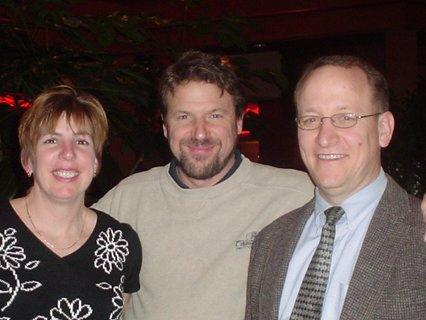The man in the middle has what feature? Please explain your reasoning. goatee. The facial hair is like a beard but does not cover the man's entire lower face. 